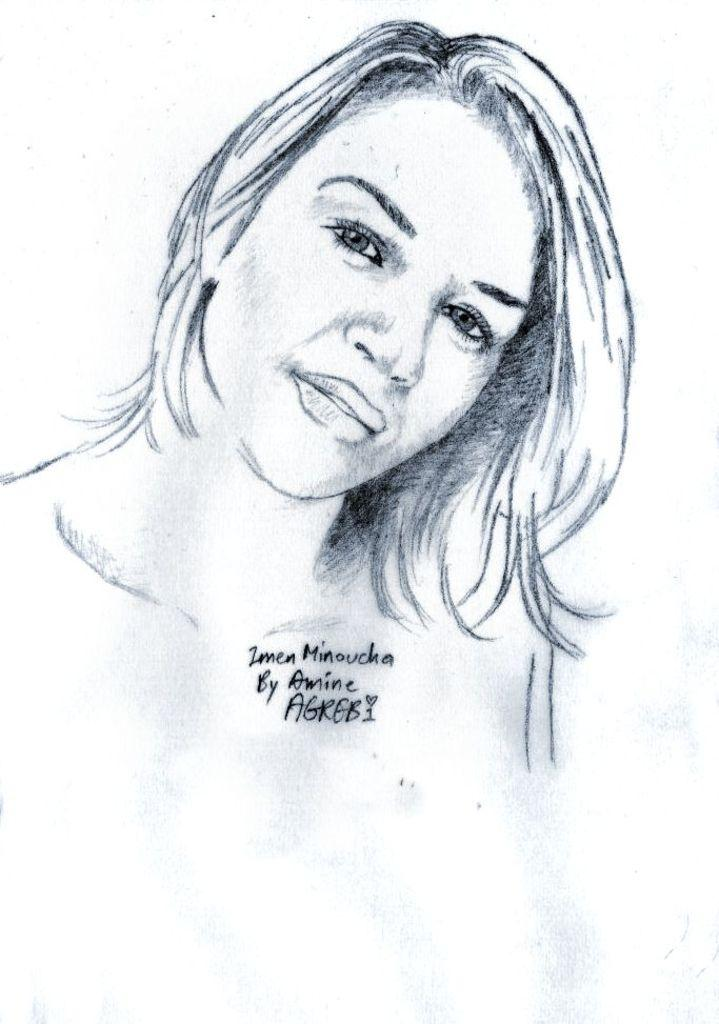What is the main subject of the image? The main subject of the image is an art piece. Can you describe the art piece in the image? The art piece has text on it. How many frogs are jumping on the crate in the image? There are no frogs or crates present in the image. The image only features an art piece with text on it. 